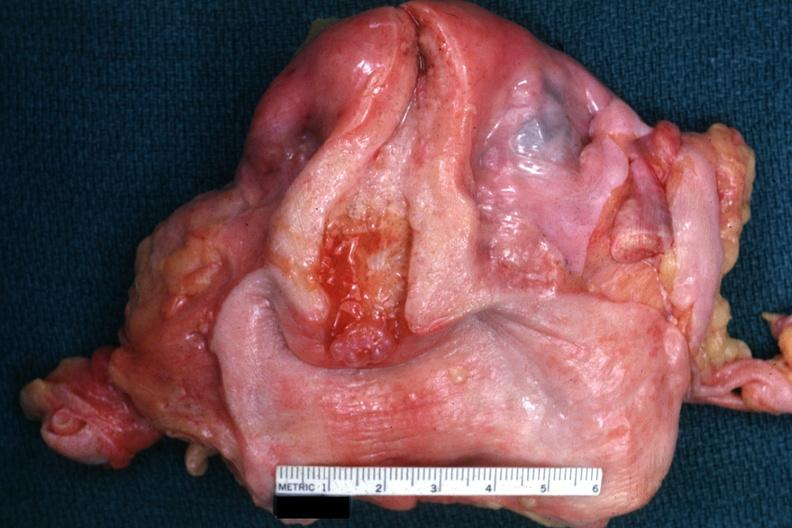does typical tuberculous exudate show excellent example with opened uterus and cervix and vagina?
Answer the question using a single word or phrase. No 